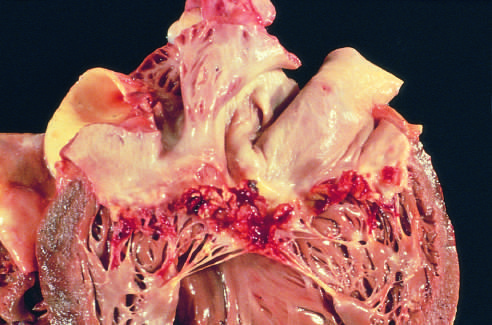what is subacute endocarditis caused by?
Answer the question using a single word or phrase. Streptococcus viridans on a previously myxomatous mitral valve 